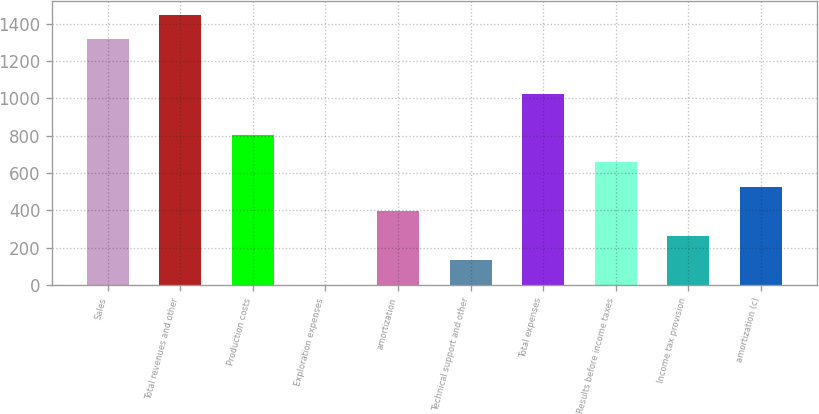Convert chart. <chart><loc_0><loc_0><loc_500><loc_500><bar_chart><fcel>Sales<fcel>Total revenues and other<fcel>Production costs<fcel>Exploration expenses<fcel>amortization<fcel>Technical support and other<fcel>Total expenses<fcel>Results before income taxes<fcel>Income tax provision<fcel>amortization (c)<nl><fcel>1316<fcel>1447.5<fcel>803<fcel>1<fcel>395.5<fcel>132.5<fcel>1025<fcel>658.5<fcel>264<fcel>527<nl></chart> 